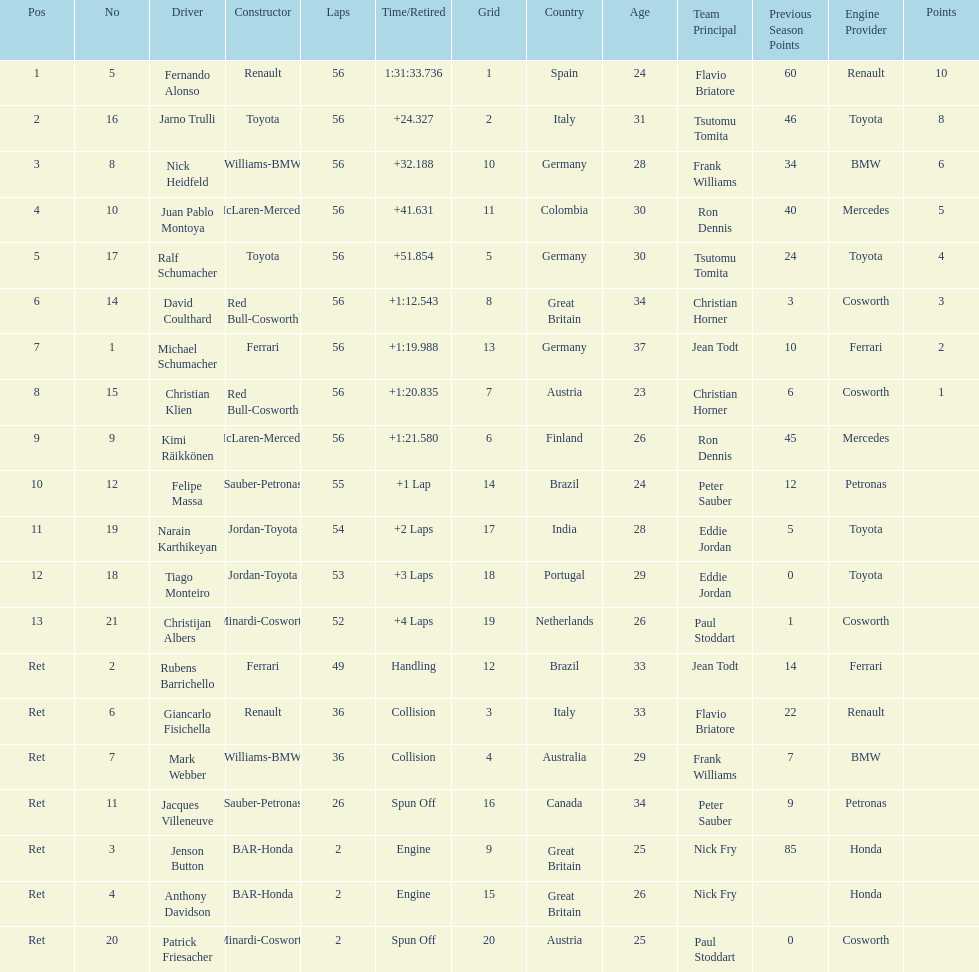What were the total number of laps completed by the 1st position winner? 56. 